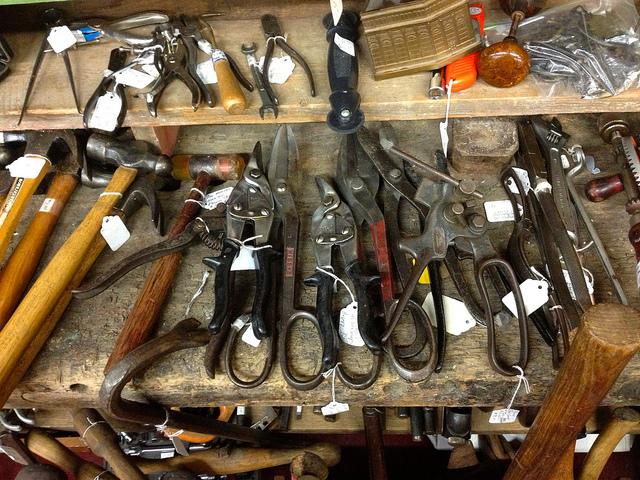Are these in a maintenance room?
Answer briefly. Yes. How many sharks are there?
Short answer required. 3. Do you see a hand saw?
Short answer required. No. 